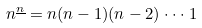<formula> <loc_0><loc_0><loc_500><loc_500>n ^ { \underline { n } } = n ( n - 1 ) ( n - 2 ) \cdot \cdot \cdot 1</formula> 